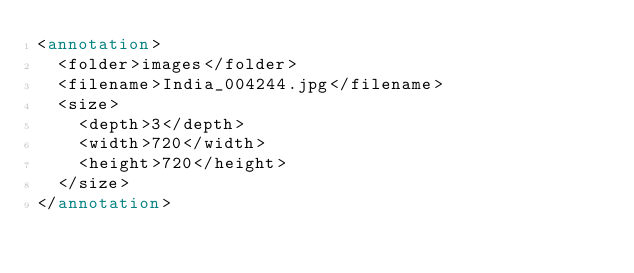Convert code to text. <code><loc_0><loc_0><loc_500><loc_500><_XML_><annotation>
  <folder>images</folder>
  <filename>India_004244.jpg</filename>
  <size>
    <depth>3</depth>
    <width>720</width>
    <height>720</height>
  </size>
</annotation></code> 